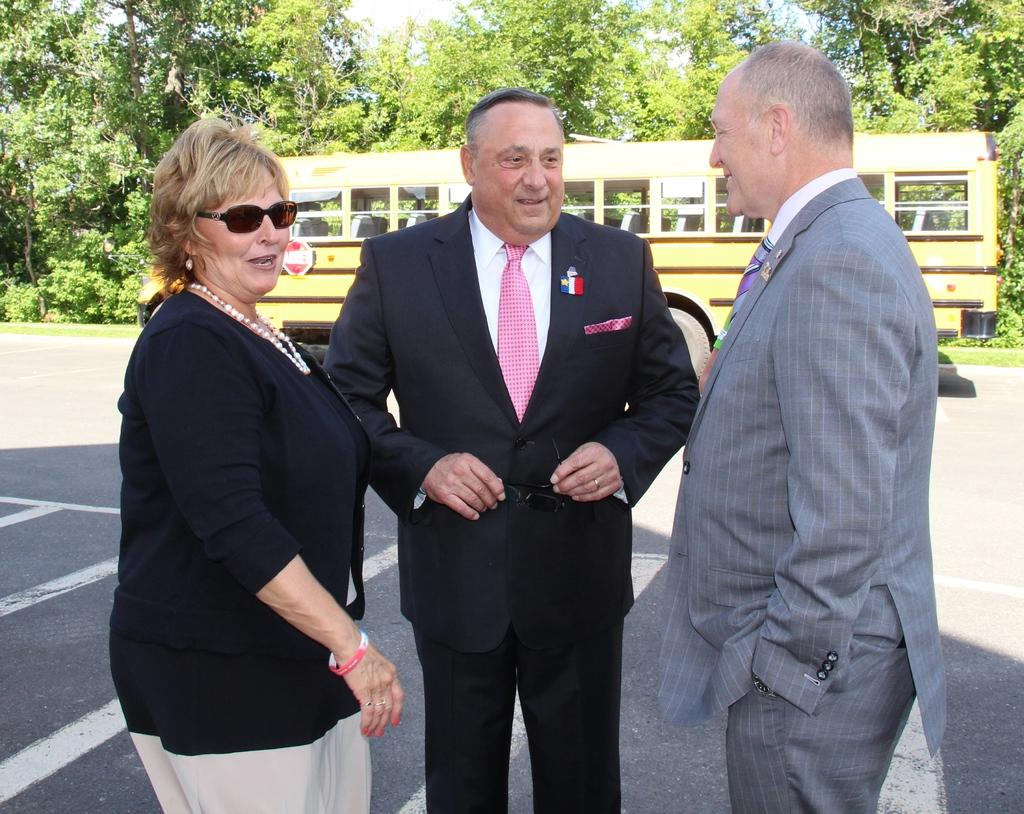How many people are in the image? There are three people in the image. What are the people doing in the image? The people are standing and smiling. What is the man holding in the image? The man is holding goggles. What can be seen in the background of the image? There is a bus, trees, and the sky visible in the background of the image. How many spiders are crawling on the people in the image? There are no spiders visible in the image; the people are standing and smiling. What type of show is being performed by the people in the image? There is no indication of a show or performance in the image; the people are simply standing and smiling. 